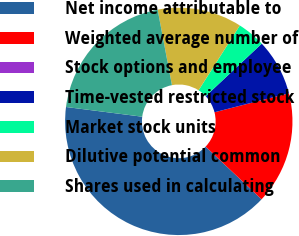<chart> <loc_0><loc_0><loc_500><loc_500><pie_chart><fcel>Net income attributable to<fcel>Weighted average number of<fcel>Stock options and employee<fcel>Time-vested restricted stock<fcel>Market stock units<fcel>Dilutive potential common<fcel>Shares used in calculating<nl><fcel>40.0%<fcel>16.0%<fcel>0.0%<fcel>8.0%<fcel>4.0%<fcel>12.0%<fcel>20.0%<nl></chart> 